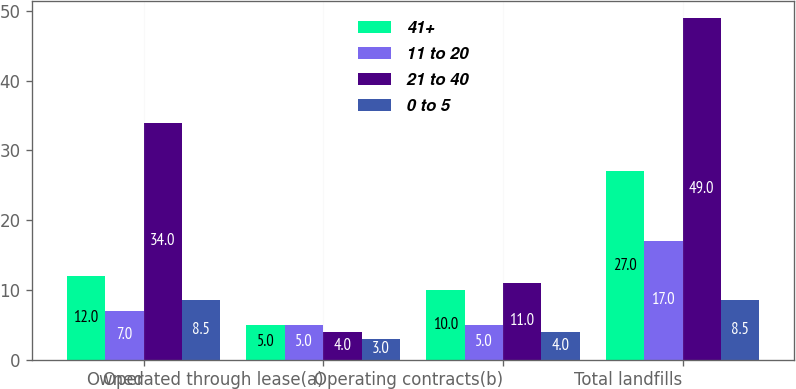Convert chart to OTSL. <chart><loc_0><loc_0><loc_500><loc_500><stacked_bar_chart><ecel><fcel>Owned<fcel>Operated through lease(a)<fcel>Operating contracts(b)<fcel>Total landfills<nl><fcel>41+<fcel>12<fcel>5<fcel>10<fcel>27<nl><fcel>11 to 20<fcel>7<fcel>5<fcel>5<fcel>17<nl><fcel>21 to 40<fcel>34<fcel>4<fcel>11<fcel>49<nl><fcel>0 to 5<fcel>8.5<fcel>3<fcel>4<fcel>8.5<nl></chart> 